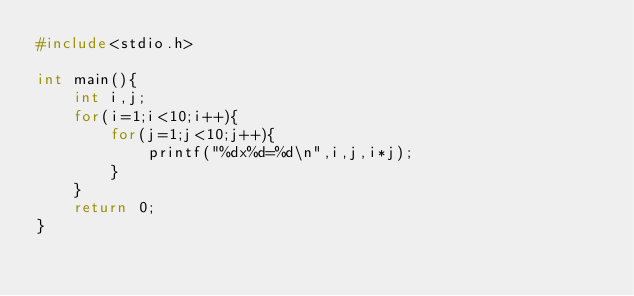<code> <loc_0><loc_0><loc_500><loc_500><_C_>#include<stdio.h>

int main(){
    int i,j;
    for(i=1;i<10;i++){
        for(j=1;j<10;j++){
            printf("%dx%d=%d\n",i,j,i*j);
        }
    }
    return 0;
}</code> 